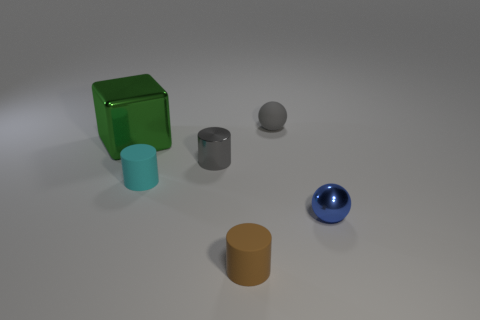Subtract all brown cylinders. How many cylinders are left? 2 Subtract all blue spheres. How many spheres are left? 1 Subtract 1 spheres. How many spheres are left? 1 Add 3 tiny brown things. How many objects exist? 9 Add 5 rubber things. How many rubber things are left? 8 Add 3 large red matte blocks. How many large red matte blocks exist? 3 Subtract 0 green balls. How many objects are left? 6 Subtract all blocks. How many objects are left? 5 Subtract all green cylinders. Subtract all cyan blocks. How many cylinders are left? 3 Subtract all objects. Subtract all blue matte balls. How many objects are left? 0 